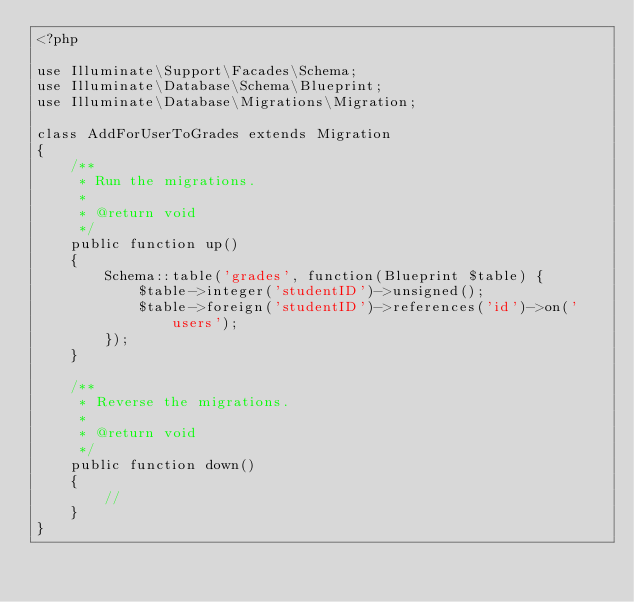Convert code to text. <code><loc_0><loc_0><loc_500><loc_500><_PHP_><?php

use Illuminate\Support\Facades\Schema;
use Illuminate\Database\Schema\Blueprint;
use Illuminate\Database\Migrations\Migration;

class AddForUserToGrades extends Migration
{
    /**
     * Run the migrations.
     *
     * @return void
     */
    public function up()
    {
        Schema::table('grades', function(Blueprint $table) {
            $table->integer('studentID')->unsigned();
            $table->foreign('studentID')->references('id')->on('users');
        });
    }

    /**
     * Reverse the migrations.
     *
     * @return void
     */
    public function down()
    {
        //
    }
}
</code> 